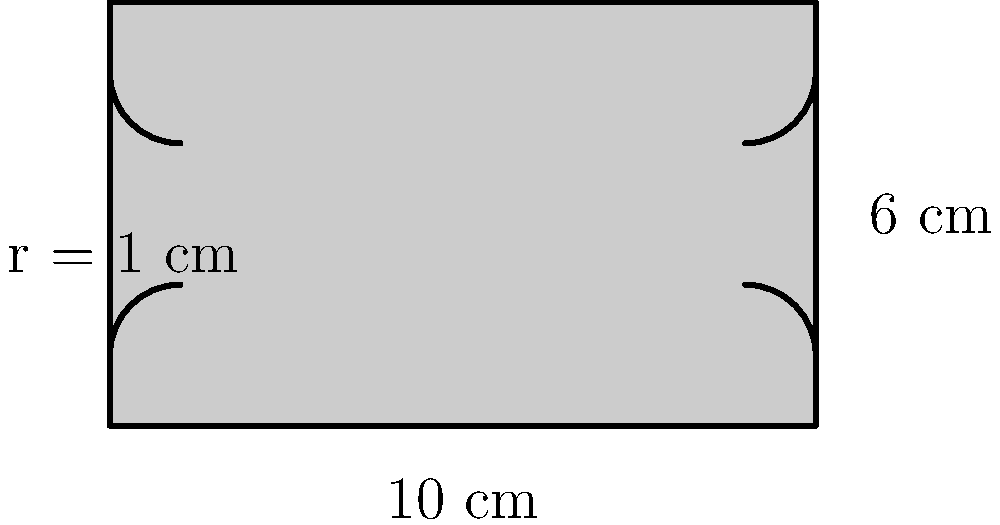A curious cat notices a rectangular radio with rounded corners on the shelf. The radio measures 10 cm in length and 6 cm in width, with a corner radius of 1 cm. What is the perimeter of this radio? To find the perimeter of the radio with rounded corners, we need to:

1) Calculate the perimeter of the rectangle without considering the rounded corners:
   $$P_{rectangle} = 2(l + w) = 2(10 + 6) = 32\text{ cm}$$

2) Subtract the length of the straight edges removed by the rounded corners:
   $$L_{removed} = 4(2r) = 4(2 \cdot 1) = 8\text{ cm}$$

3) Add the length of the circular arcs that form the rounded corners:
   $$L_{arcs} = 2\pi r = 2\pi \cdot 1 = 2\pi\text{ cm}$$

4) Combine these to get the final perimeter:
   $$P_{total} = P_{rectangle} - L_{removed} + L_{arcs}$$
   $$P_{total} = 32 - 8 + 2\pi = 24 + 2\pi\text{ cm}$$

5) Simplify:
   $$P_{total} \approx 30.28\text{ cm}$$
Answer: $24 + 2\pi\text{ cm}$ or approximately $30.28\text{ cm}$ 